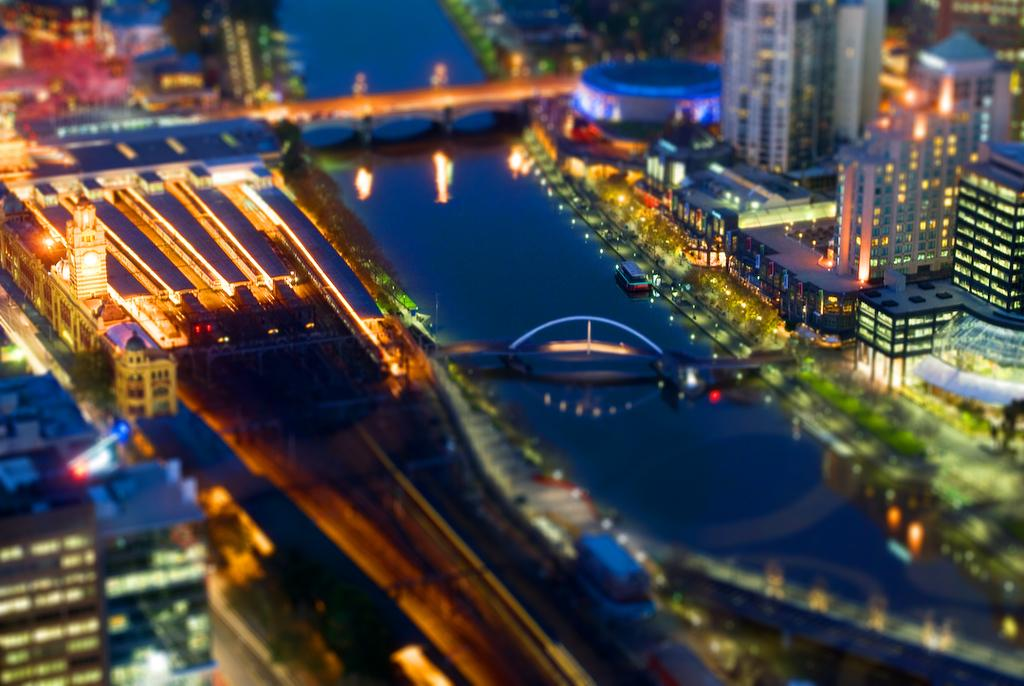What type of view is shown in the image? The image is an aerial view. What structures can be seen in the image? There are buildings in the image. What is the prominent feature in the center of the image? There is a bridge in the center of the image. What natural feature is visible in the image? There is a lake visible in the image. Can you describe any activity happening on the lake? There is a boat on the lake. What else can be observed in the image? There are lights present in the image. What type of silk is being produced by the beast in the society depicted in the image? There is no beast or society present in the image, and silk production is not mentioned. 